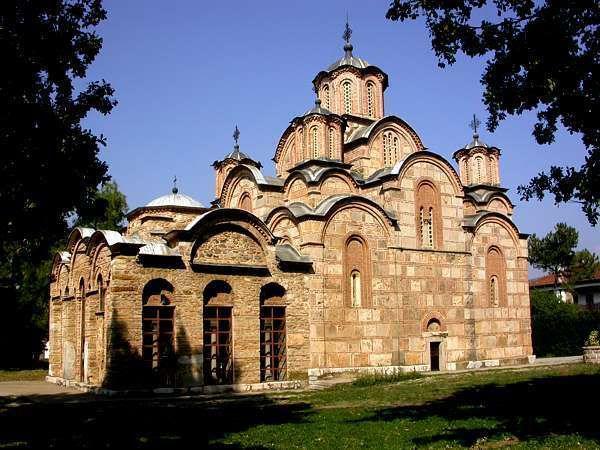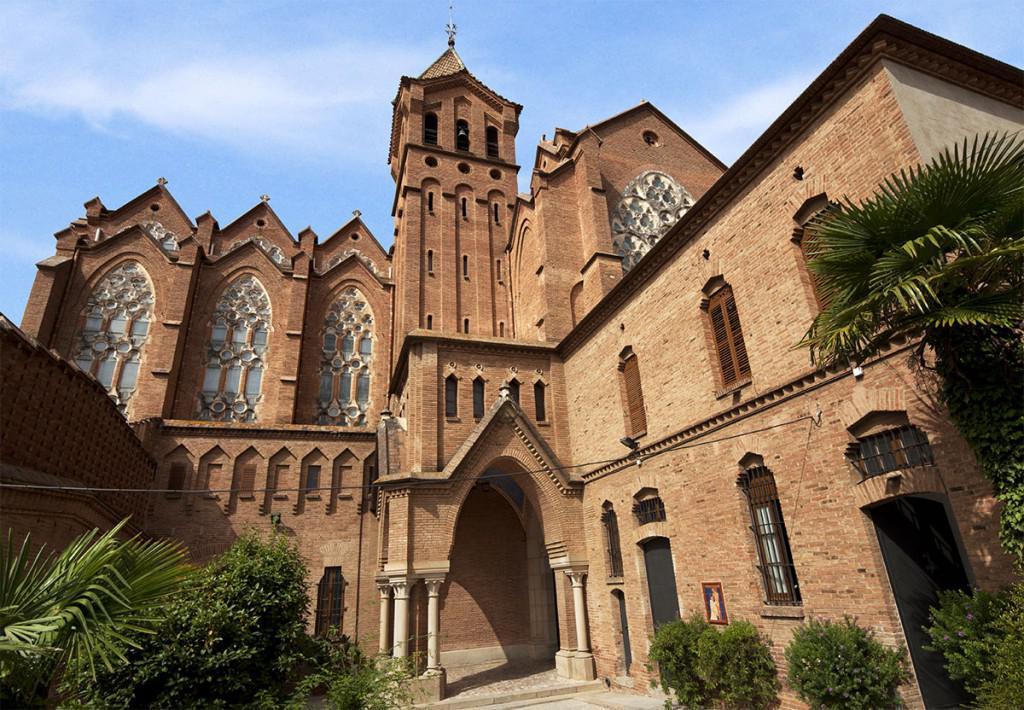The first image is the image on the left, the second image is the image on the right. Evaluate the accuracy of this statement regarding the images: "An image shows a tall building with a flat top that is notched like a castle.". Is it true? Answer yes or no. No. 